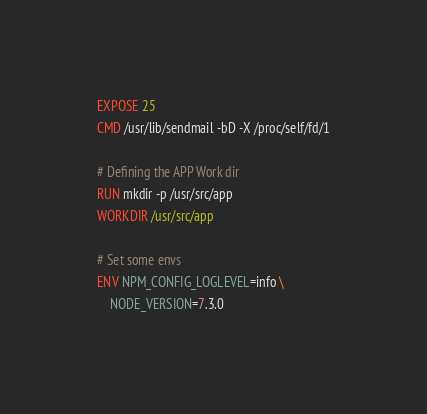Convert code to text. <code><loc_0><loc_0><loc_500><loc_500><_Dockerfile_>
EXPOSE 25
CMD /usr/lib/sendmail -bD -X /proc/self/fd/1

# Defining the APP Work dir 
RUN mkdir -p /usr/src/app
WORKDIR /usr/src/app

# Set some envs
ENV NPM_CONFIG_LOGLEVEL=info \
    NODE_VERSION=7.3.0</code> 